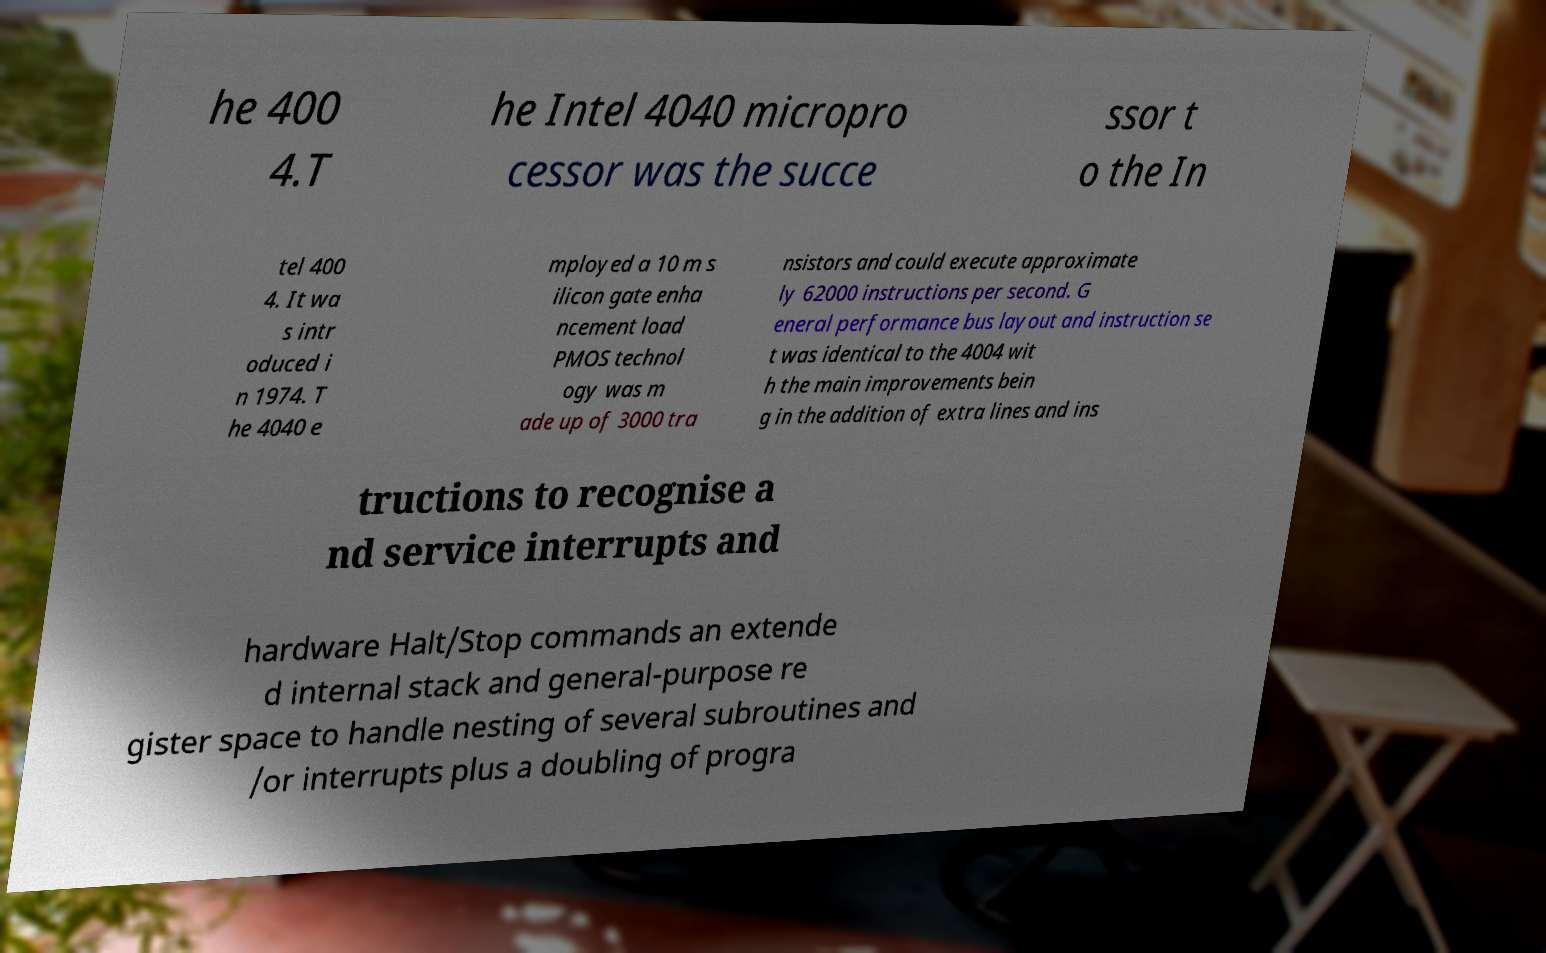Could you assist in decoding the text presented in this image and type it out clearly? he 400 4.T he Intel 4040 micropro cessor was the succe ssor t o the In tel 400 4. It wa s intr oduced i n 1974. T he 4040 e mployed a 10 m s ilicon gate enha ncement load PMOS technol ogy was m ade up of 3000 tra nsistors and could execute approximate ly 62000 instructions per second. G eneral performance bus layout and instruction se t was identical to the 4004 wit h the main improvements bein g in the addition of extra lines and ins tructions to recognise a nd service interrupts and hardware Halt/Stop commands an extende d internal stack and general-purpose re gister space to handle nesting of several subroutines and /or interrupts plus a doubling of progra 